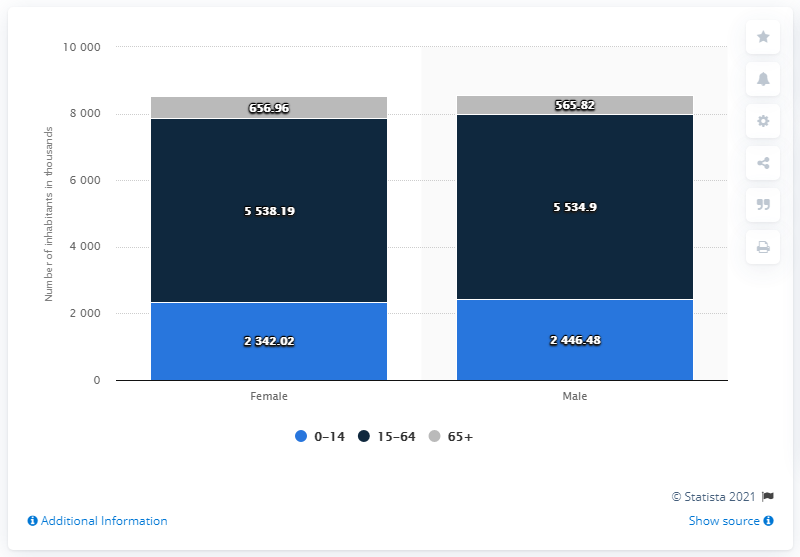List a handful of essential elements in this visual. The population of females in the age group of 0-14 years is 23,420.2. The maximum population of males in a certain age group is different from the minimum population of females in another age group, with a difference of approximately 4877.94. 